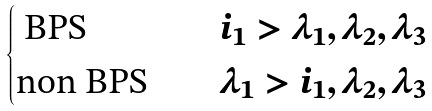Convert formula to latex. <formula><loc_0><loc_0><loc_500><loc_500>\begin{cases} \text { BPS} \quad & i _ { 1 } > \lambda _ { 1 } , \lambda _ { 2 } , \lambda _ { 3 } \\ \text {non BPS} \quad & \lambda _ { 1 } > i _ { 1 } , \lambda _ { 2 } , \lambda _ { 3 } \end{cases}</formula> 